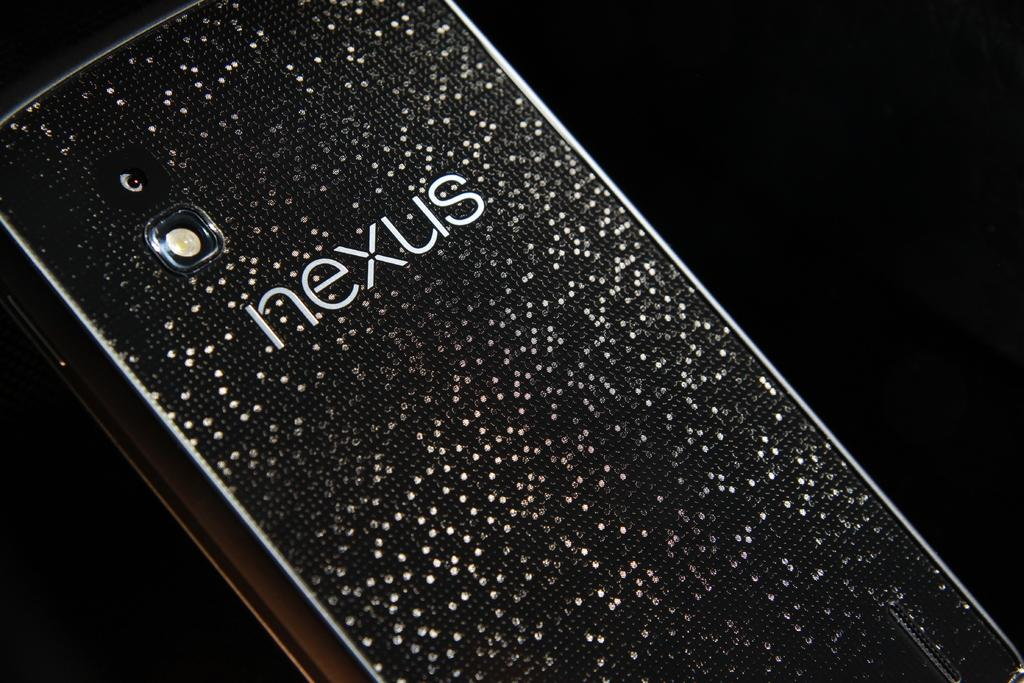<image>
Offer a succinct explanation of the picture presented. Black and white cellphone with the word NEXUS on the back. 